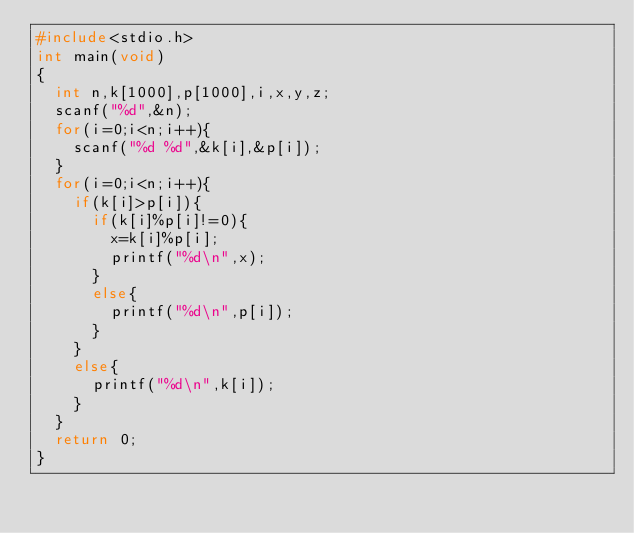<code> <loc_0><loc_0><loc_500><loc_500><_C_>#include<stdio.h>
int main(void)
{
	int n,k[1000],p[1000],i,x,y,z;
	scanf("%d",&n);
	for(i=0;i<n;i++){
		scanf("%d %d",&k[i],&p[i]);
	}
	for(i=0;i<n;i++){
		if(k[i]>p[i]){
			if(k[i]%p[i]!=0){
				x=k[i]%p[i];
				printf("%d\n",x);
			}
			else{
				printf("%d\n",p[i]);
			}
		}
		else{
			printf("%d\n",k[i]);
		}
	}
	return 0;
}
</code> 